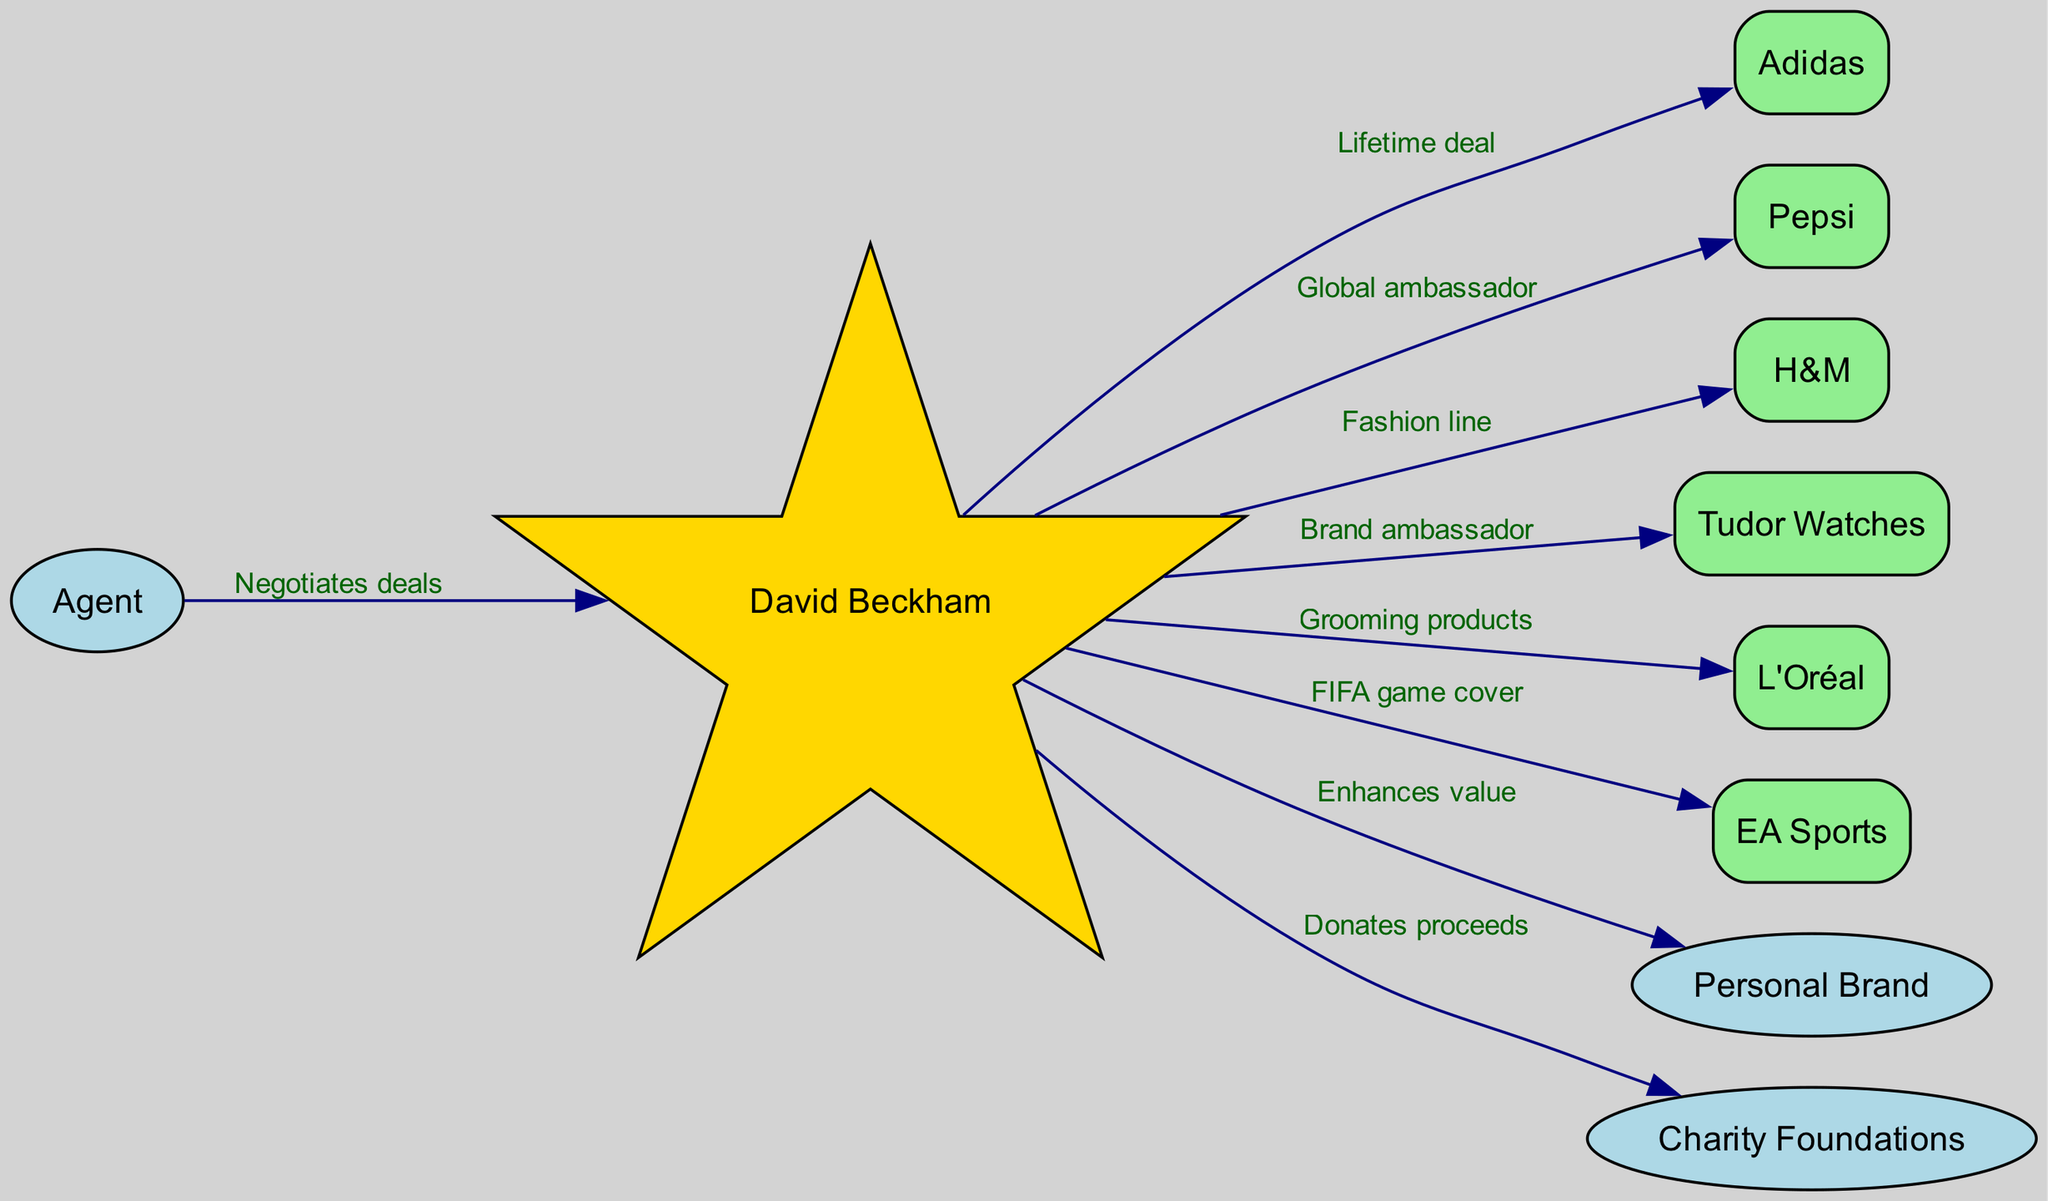What type of deal does David Beckham have with Adidas? The edge connecting David Beckham and Adidas is labeled "Lifetime deal", which indicates the type of relationship they have.
Answer: Lifetime deal How many brands is David Beckham associated with in the diagram? By counting the edges leading from David Beckham to various brands, we see that he is connected to six brands: Adidas, Pepsi, H&M, Tudor Watches, L'Oréal, and EA Sports.
Answer: Six Who negotiates deals for David Beckham? The edge shows an arrow from the "Agent" node to "David Beckham," indicating the agent's role in negotiating deals for him.
Answer: Agent What does David Beckham do with the proceeds from sponsorships? The diagram shows an edge pointing from David Beckham to "Charity Foundations" labeled "Donates proceeds," indicating what he does with the proceeds.
Answer: Donates proceeds How does David Beckham enhance his personal brand? The connection from David Beckham to "Personal Brand" labeled "Enhances value" shows the nature of this relationship, clarifying how he contributes to his own brand's value.
Answer: Enhances value Which brand does not have a direct edge from David Beckham? By reviewing the connections, we find that there are no edges leading to or from the "Agent" or "Charity Foundations," making them unique. However, if the question is looking for brands only, "Charity Foundations" is the answer.
Answer: Charity Foundations Which brand is associated with grooming products in Beckham's deals? The edge connecting David Beckham to L'Oréal is labeled "Grooming products," signifying the specific category of the endorsement deal.
Answer: L'Oréal What is the connection between David Beckham and EA Sports? The directed edge from David Beckham to EA Sports is labeled "FIFA game cover," thus explaining the nature of their relationship.
Answer: FIFA game cover How many nodes are linked to David Beckham directly? Looking at David Beckham's connections, we find he is directly linked to seven nodes: Adidas, Pepsi, H&M, Tudor Watches, L'Oréal, EA Sports, and Charity Foundations, totaling seven connections.
Answer: Seven 